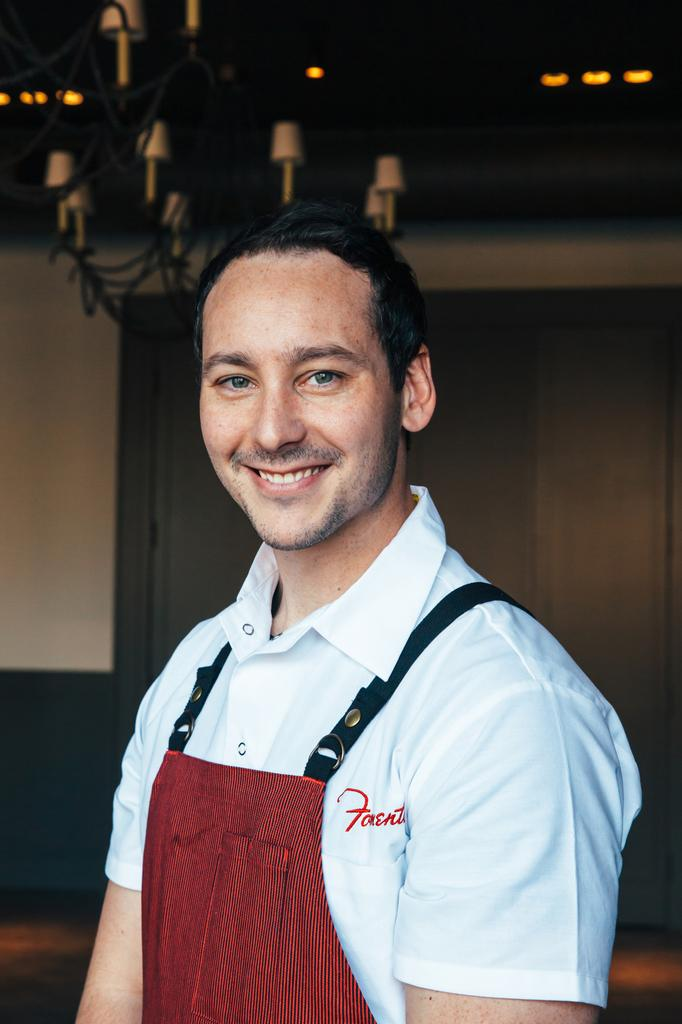<image>
Offer a succinct explanation of the picture presented. The word on the shirt of the man wearing the red apron begins with the letter F. 